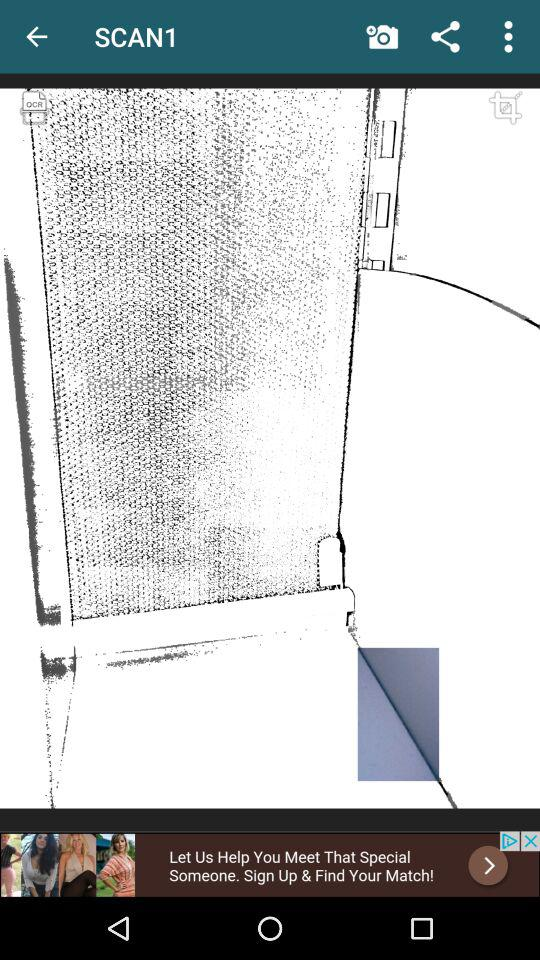What is the application name? The application name is "Quick PDF Scanner". 